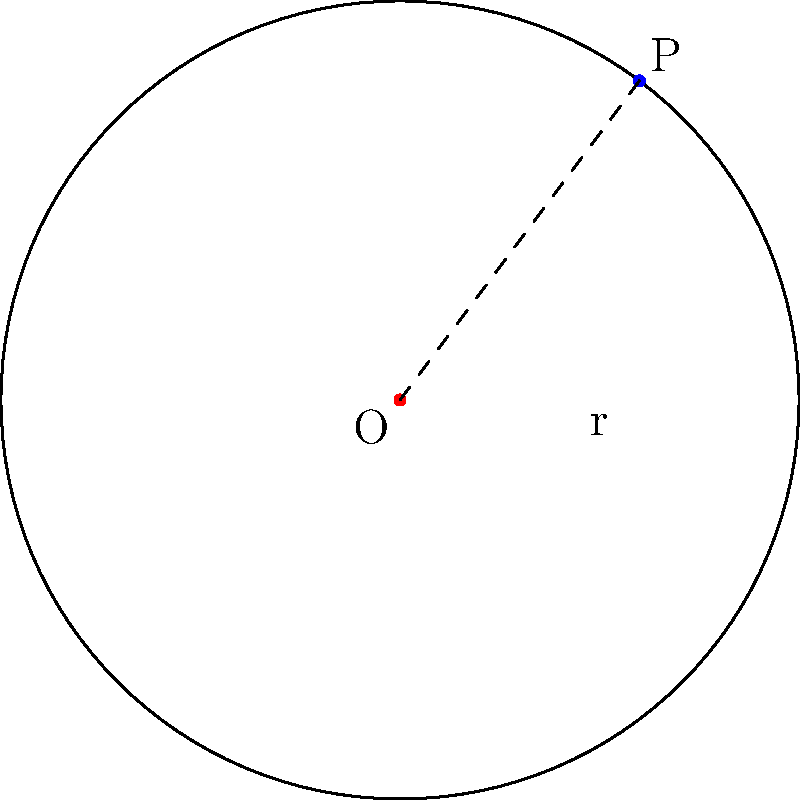A circular stage with a radius of 5 meters is being designed for a comedian's comeback performance. The optimal position for the comedian is determined to be at point P(3,4) relative to the center of the stage O(0,0). What percentage of the stage area is within the comedian's reach if they can cover a circular area with a radius equal to their distance from the center of the stage? To solve this problem, we'll follow these steps:

1) First, calculate the distance of point P from the center O:
   $$d = \sqrt{3^2 + 4^2} = \sqrt{9 + 16} = \sqrt{25} = 5$$

2) The comedian can cover a circular area with radius 5m from point P.

3) Calculate the area of the entire stage:
   $$A_{stage} = \pi r^2 = \pi (5^2) = 25\pi$$

4) The area covered by the comedian and the stage form two circles that intersect. We need to find the area of this intersection.

5) In this case, the two circles are identical and their centers are exactly 5m apart (equal to their radii). This means they intersect at exactly one point on the stage's circumference.

6) The area of intersection of two identical circles touching at one point is:
   $$A_{intersection} = \frac{2\pi r^2}{3} = \frac{2\pi (5^2)}{3} = \frac{50\pi}{3}$$

7) Calculate the percentage:
   $$\text{Percentage} = \frac{A_{intersection}}{A_{stage}} \times 100\% = \frac{50\pi/3}{25\pi} \times 100\% = \frac{2}{3} \times 100\% = 66.67\%$$

Thus, the comedian can reach approximately 66.67% of the stage area from their optimal position.
Answer: 66.67% 